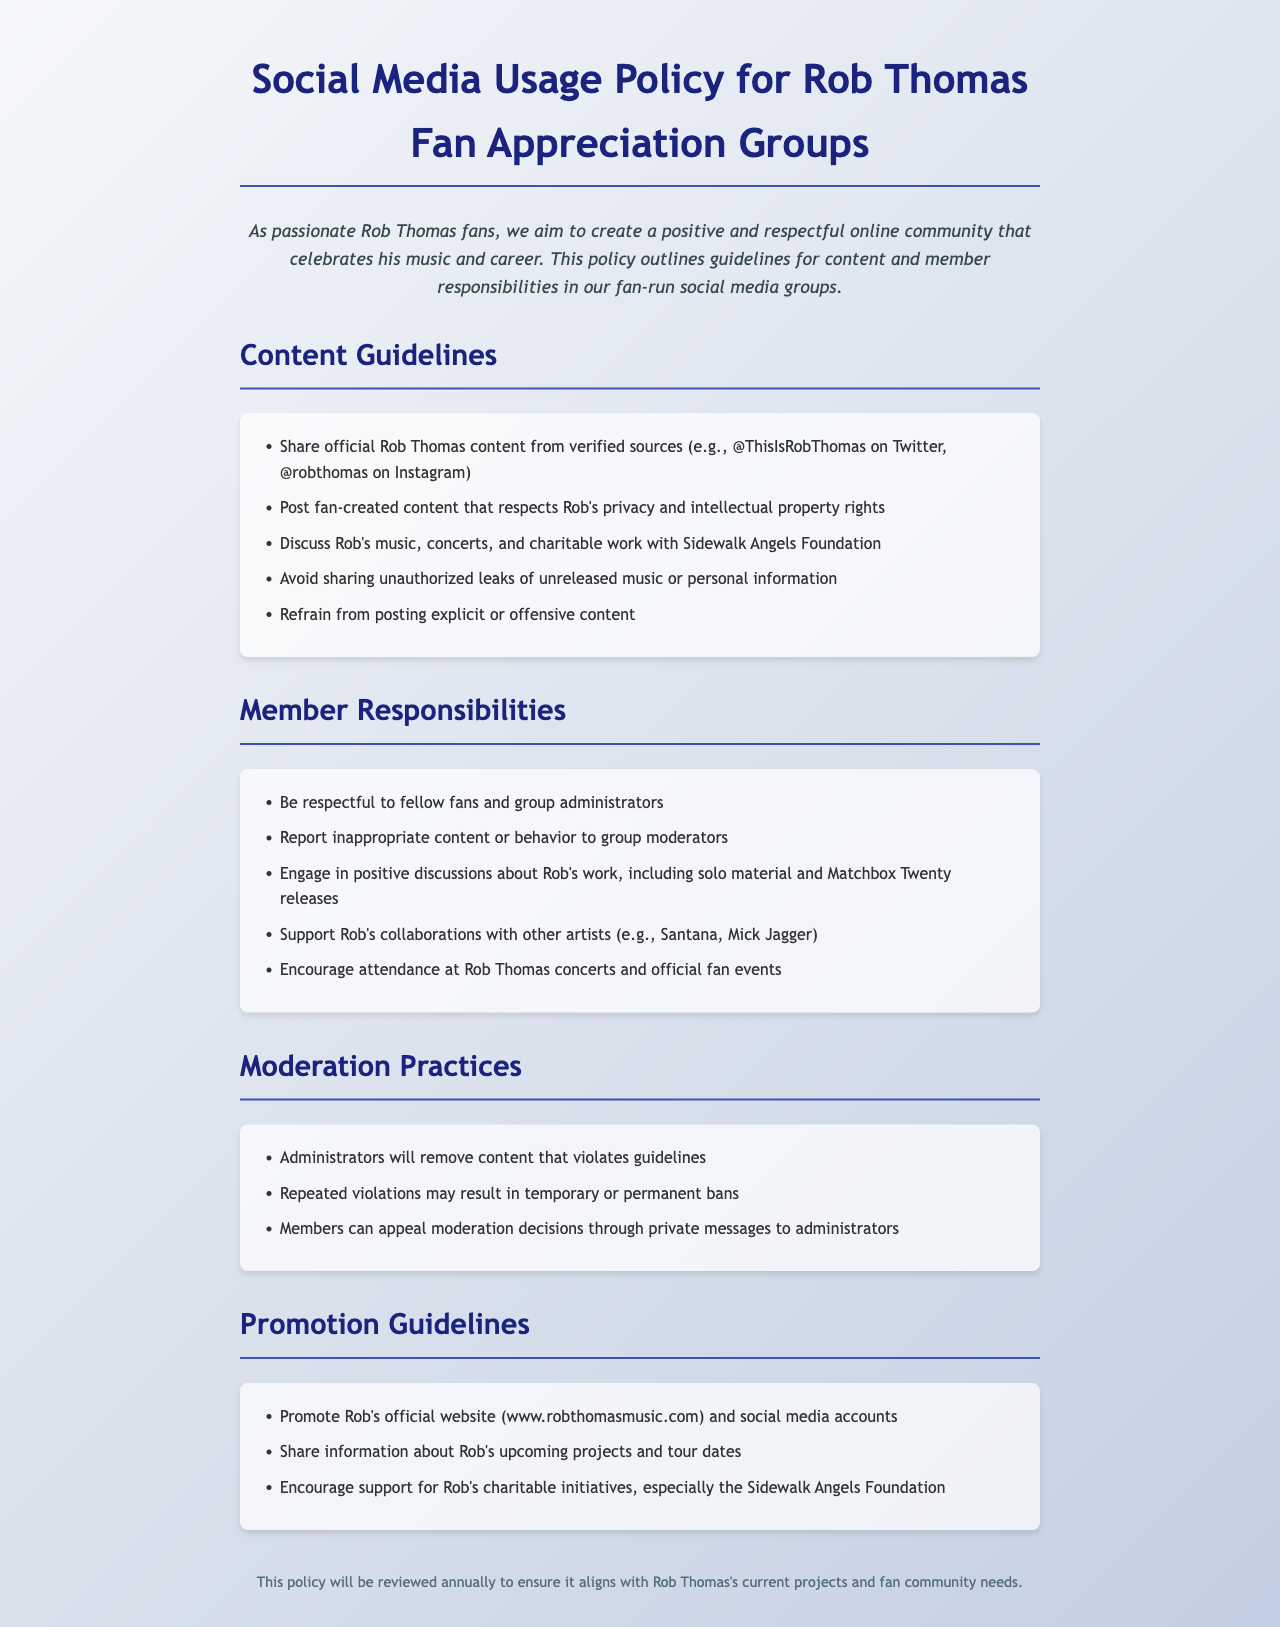What is the title of the policy document? The title of the document is prominently displayed at the top of the page, indicating its focus on social media usage for fan appreciation groups.
Answer: Social Media Usage Policy for Rob Thomas Fan Appreciation Groups What foundation is mentioned in the document? The document highlights Rob Thomas's charitable involvement, specifically naming the organization.
Answer: Sidewalk Angels Foundation What should members do if they see inappropriate content? Members are instructed to take a specific action when they encounter content that violates the guidelines.
Answer: Report to group moderators How often will the policy be reviewed? The document specifies the frequency of its review to keep it current with Rob Thomas's projects and community needs.
Answer: Annually What type of content should be avoided according to the guidelines? The document explicitly advises against a certain type of content that can be deemed offensive or inappropriate.
Answer: Explicit or offensive content Which artist collaborations are encouraged to be supported? The document lists specific artists that members should show support for regarding their work with Rob Thomas.
Answer: Santana, Mick Jagger What can happen to members who repeatedly violate the rules? The policy outlines the potential consequences for members who don't adhere to the established guidelines.
Answer: Temporary or permanent bans What is the main goal of the fan appreciation groups? The introduction provides insight into the overarching aim of these groups as related to the artist and his work.
Answer: Create a positive and respectful online community 